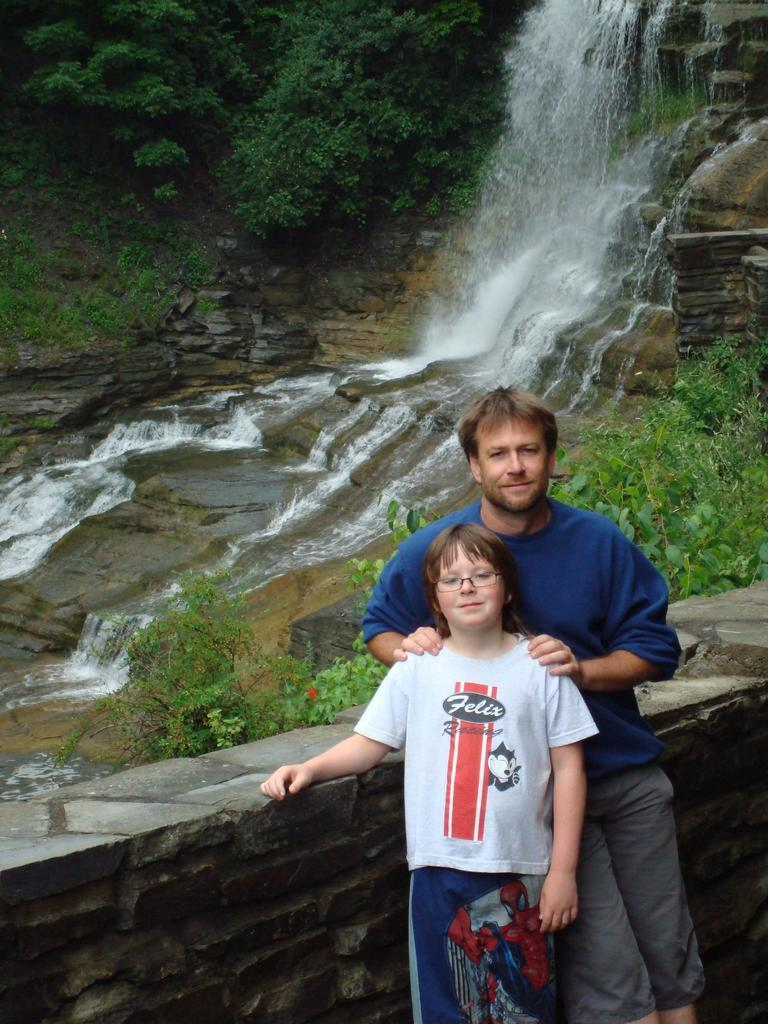How many people are in the image? There are two persons in the image. Where are the persons located in relation to the wall? The persons are standing near a wall. What can be seen in the background of the image? There is a waterfall and trees in the background of the image. What type of twig is being used for division in the image? There is no twig or division present in the image. 